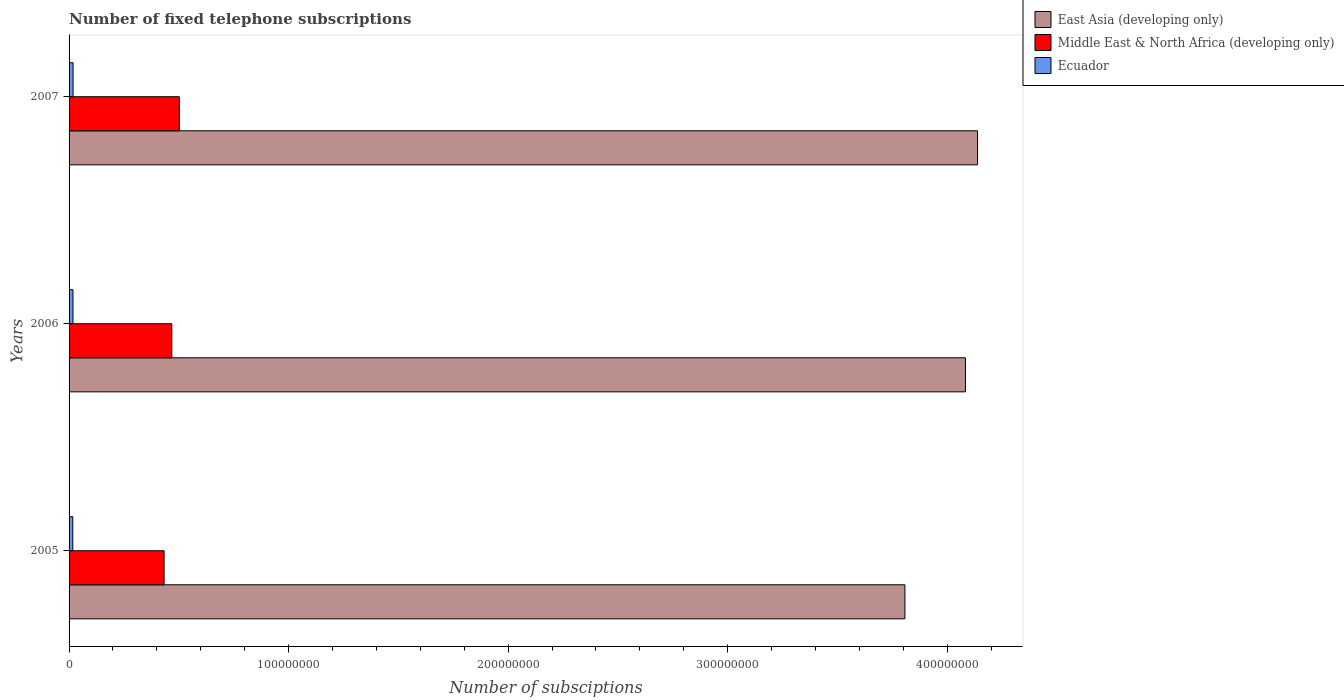How many different coloured bars are there?
Your answer should be compact. 3. Are the number of bars per tick equal to the number of legend labels?
Your response must be concise. Yes. How many bars are there on the 3rd tick from the bottom?
Give a very brief answer. 3. In how many cases, is the number of bars for a given year not equal to the number of legend labels?
Keep it short and to the point. 0. What is the number of fixed telephone subscriptions in Middle East & North Africa (developing only) in 2005?
Provide a short and direct response. 4.33e+07. Across all years, what is the maximum number of fixed telephone subscriptions in Ecuador?
Give a very brief answer. 1.82e+06. Across all years, what is the minimum number of fixed telephone subscriptions in Middle East & North Africa (developing only)?
Ensure brevity in your answer.  4.33e+07. In which year was the number of fixed telephone subscriptions in Ecuador maximum?
Your response must be concise. 2007. What is the total number of fixed telephone subscriptions in Middle East & North Africa (developing only) in the graph?
Keep it short and to the point. 1.40e+08. What is the difference between the number of fixed telephone subscriptions in East Asia (developing only) in 2005 and that in 2006?
Keep it short and to the point. -2.76e+07. What is the difference between the number of fixed telephone subscriptions in East Asia (developing only) in 2006 and the number of fixed telephone subscriptions in Ecuador in 2005?
Your response must be concise. 4.07e+08. What is the average number of fixed telephone subscriptions in Ecuador per year?
Keep it short and to the point. 1.76e+06. In the year 2007, what is the difference between the number of fixed telephone subscriptions in Middle East & North Africa (developing only) and number of fixed telephone subscriptions in East Asia (developing only)?
Offer a very short reply. -3.64e+08. What is the ratio of the number of fixed telephone subscriptions in Middle East & North Africa (developing only) in 2005 to that in 2007?
Make the answer very short. 0.86. Is the number of fixed telephone subscriptions in Ecuador in 2005 less than that in 2006?
Your answer should be very brief. Yes. Is the difference between the number of fixed telephone subscriptions in Middle East & North Africa (developing only) in 2005 and 2007 greater than the difference between the number of fixed telephone subscriptions in East Asia (developing only) in 2005 and 2007?
Provide a succinct answer. Yes. What is the difference between the highest and the second highest number of fixed telephone subscriptions in Ecuador?
Your response must be concise. 4.79e+04. What is the difference between the highest and the lowest number of fixed telephone subscriptions in Ecuador?
Provide a succinct answer. 1.44e+05. What does the 1st bar from the top in 2005 represents?
Your response must be concise. Ecuador. What does the 3rd bar from the bottom in 2005 represents?
Your answer should be compact. Ecuador. Is it the case that in every year, the sum of the number of fixed telephone subscriptions in East Asia (developing only) and number of fixed telephone subscriptions in Ecuador is greater than the number of fixed telephone subscriptions in Middle East & North Africa (developing only)?
Your response must be concise. Yes. How many bars are there?
Your answer should be very brief. 9. Are all the bars in the graph horizontal?
Offer a very short reply. Yes. How many years are there in the graph?
Your answer should be very brief. 3. Are the values on the major ticks of X-axis written in scientific E-notation?
Keep it short and to the point. No. What is the title of the graph?
Offer a terse response. Number of fixed telephone subscriptions. Does "Cote d'Ivoire" appear as one of the legend labels in the graph?
Make the answer very short. No. What is the label or title of the X-axis?
Offer a very short reply. Number of subsciptions. What is the Number of subsciptions of East Asia (developing only) in 2005?
Provide a succinct answer. 3.81e+08. What is the Number of subsciptions in Middle East & North Africa (developing only) in 2005?
Offer a terse response. 4.33e+07. What is the Number of subsciptions of Ecuador in 2005?
Offer a terse response. 1.68e+06. What is the Number of subsciptions in East Asia (developing only) in 2006?
Provide a short and direct response. 4.08e+08. What is the Number of subsciptions in Middle East & North Africa (developing only) in 2006?
Keep it short and to the point. 4.68e+07. What is the Number of subsciptions of Ecuador in 2006?
Provide a succinct answer. 1.78e+06. What is the Number of subsciptions of East Asia (developing only) in 2007?
Make the answer very short. 4.14e+08. What is the Number of subsciptions in Middle East & North Africa (developing only) in 2007?
Provide a short and direct response. 5.02e+07. What is the Number of subsciptions in Ecuador in 2007?
Make the answer very short. 1.82e+06. Across all years, what is the maximum Number of subsciptions of East Asia (developing only)?
Your response must be concise. 4.14e+08. Across all years, what is the maximum Number of subsciptions of Middle East & North Africa (developing only)?
Give a very brief answer. 5.02e+07. Across all years, what is the maximum Number of subsciptions in Ecuador?
Your answer should be very brief. 1.82e+06. Across all years, what is the minimum Number of subsciptions in East Asia (developing only)?
Your answer should be compact. 3.81e+08. Across all years, what is the minimum Number of subsciptions in Middle East & North Africa (developing only)?
Make the answer very short. 4.33e+07. Across all years, what is the minimum Number of subsciptions in Ecuador?
Ensure brevity in your answer.  1.68e+06. What is the total Number of subsciptions of East Asia (developing only) in the graph?
Give a very brief answer. 1.20e+09. What is the total Number of subsciptions in Middle East & North Africa (developing only) in the graph?
Your answer should be compact. 1.40e+08. What is the total Number of subsciptions in Ecuador in the graph?
Give a very brief answer. 5.28e+06. What is the difference between the Number of subsciptions in East Asia (developing only) in 2005 and that in 2006?
Offer a very short reply. -2.76e+07. What is the difference between the Number of subsciptions in Middle East & North Africa (developing only) in 2005 and that in 2006?
Ensure brevity in your answer.  -3.52e+06. What is the difference between the Number of subsciptions of Ecuador in 2005 and that in 2006?
Make the answer very short. -9.57e+04. What is the difference between the Number of subsciptions of East Asia (developing only) in 2005 and that in 2007?
Provide a succinct answer. -3.31e+07. What is the difference between the Number of subsciptions of Middle East & North Africa (developing only) in 2005 and that in 2007?
Provide a short and direct response. -6.94e+06. What is the difference between the Number of subsciptions in Ecuador in 2005 and that in 2007?
Your answer should be compact. -1.44e+05. What is the difference between the Number of subsciptions in East Asia (developing only) in 2006 and that in 2007?
Offer a very short reply. -5.51e+06. What is the difference between the Number of subsciptions of Middle East & North Africa (developing only) in 2006 and that in 2007?
Provide a succinct answer. -3.42e+06. What is the difference between the Number of subsciptions of Ecuador in 2006 and that in 2007?
Ensure brevity in your answer.  -4.79e+04. What is the difference between the Number of subsciptions in East Asia (developing only) in 2005 and the Number of subsciptions in Middle East & North Africa (developing only) in 2006?
Give a very brief answer. 3.34e+08. What is the difference between the Number of subsciptions in East Asia (developing only) in 2005 and the Number of subsciptions in Ecuador in 2006?
Provide a succinct answer. 3.79e+08. What is the difference between the Number of subsciptions of Middle East & North Africa (developing only) in 2005 and the Number of subsciptions of Ecuador in 2006?
Your response must be concise. 4.15e+07. What is the difference between the Number of subsciptions in East Asia (developing only) in 2005 and the Number of subsciptions in Middle East & North Africa (developing only) in 2007?
Offer a terse response. 3.31e+08. What is the difference between the Number of subsciptions of East Asia (developing only) in 2005 and the Number of subsciptions of Ecuador in 2007?
Your answer should be very brief. 3.79e+08. What is the difference between the Number of subsciptions of Middle East & North Africa (developing only) in 2005 and the Number of subsciptions of Ecuador in 2007?
Your answer should be compact. 4.15e+07. What is the difference between the Number of subsciptions of East Asia (developing only) in 2006 and the Number of subsciptions of Middle East & North Africa (developing only) in 2007?
Give a very brief answer. 3.58e+08. What is the difference between the Number of subsciptions of East Asia (developing only) in 2006 and the Number of subsciptions of Ecuador in 2007?
Your response must be concise. 4.07e+08. What is the difference between the Number of subsciptions in Middle East & North Africa (developing only) in 2006 and the Number of subsciptions in Ecuador in 2007?
Offer a very short reply. 4.50e+07. What is the average Number of subsciptions in East Asia (developing only) per year?
Provide a short and direct response. 4.01e+08. What is the average Number of subsciptions in Middle East & North Africa (developing only) per year?
Offer a very short reply. 4.68e+07. What is the average Number of subsciptions of Ecuador per year?
Your response must be concise. 1.76e+06. In the year 2005, what is the difference between the Number of subsciptions of East Asia (developing only) and Number of subsciptions of Middle East & North Africa (developing only)?
Offer a very short reply. 3.37e+08. In the year 2005, what is the difference between the Number of subsciptions of East Asia (developing only) and Number of subsciptions of Ecuador?
Keep it short and to the point. 3.79e+08. In the year 2005, what is the difference between the Number of subsciptions in Middle East & North Africa (developing only) and Number of subsciptions in Ecuador?
Provide a short and direct response. 4.16e+07. In the year 2006, what is the difference between the Number of subsciptions in East Asia (developing only) and Number of subsciptions in Middle East & North Africa (developing only)?
Your answer should be very brief. 3.62e+08. In the year 2006, what is the difference between the Number of subsciptions of East Asia (developing only) and Number of subsciptions of Ecuador?
Ensure brevity in your answer.  4.07e+08. In the year 2006, what is the difference between the Number of subsciptions in Middle East & North Africa (developing only) and Number of subsciptions in Ecuador?
Make the answer very short. 4.50e+07. In the year 2007, what is the difference between the Number of subsciptions of East Asia (developing only) and Number of subsciptions of Middle East & North Africa (developing only)?
Offer a terse response. 3.64e+08. In the year 2007, what is the difference between the Number of subsciptions in East Asia (developing only) and Number of subsciptions in Ecuador?
Your answer should be very brief. 4.12e+08. In the year 2007, what is the difference between the Number of subsciptions in Middle East & North Africa (developing only) and Number of subsciptions in Ecuador?
Your answer should be compact. 4.84e+07. What is the ratio of the Number of subsciptions of East Asia (developing only) in 2005 to that in 2006?
Your answer should be very brief. 0.93. What is the ratio of the Number of subsciptions in Middle East & North Africa (developing only) in 2005 to that in 2006?
Make the answer very short. 0.92. What is the ratio of the Number of subsciptions in Ecuador in 2005 to that in 2006?
Offer a very short reply. 0.95. What is the ratio of the Number of subsciptions in East Asia (developing only) in 2005 to that in 2007?
Offer a terse response. 0.92. What is the ratio of the Number of subsciptions in Middle East & North Africa (developing only) in 2005 to that in 2007?
Offer a very short reply. 0.86. What is the ratio of the Number of subsciptions in Ecuador in 2005 to that in 2007?
Your response must be concise. 0.92. What is the ratio of the Number of subsciptions of East Asia (developing only) in 2006 to that in 2007?
Your answer should be compact. 0.99. What is the ratio of the Number of subsciptions of Middle East & North Africa (developing only) in 2006 to that in 2007?
Keep it short and to the point. 0.93. What is the ratio of the Number of subsciptions of Ecuador in 2006 to that in 2007?
Make the answer very short. 0.97. What is the difference between the highest and the second highest Number of subsciptions in East Asia (developing only)?
Offer a terse response. 5.51e+06. What is the difference between the highest and the second highest Number of subsciptions in Middle East & North Africa (developing only)?
Your response must be concise. 3.42e+06. What is the difference between the highest and the second highest Number of subsciptions of Ecuador?
Offer a very short reply. 4.79e+04. What is the difference between the highest and the lowest Number of subsciptions in East Asia (developing only)?
Make the answer very short. 3.31e+07. What is the difference between the highest and the lowest Number of subsciptions of Middle East & North Africa (developing only)?
Keep it short and to the point. 6.94e+06. What is the difference between the highest and the lowest Number of subsciptions in Ecuador?
Keep it short and to the point. 1.44e+05. 